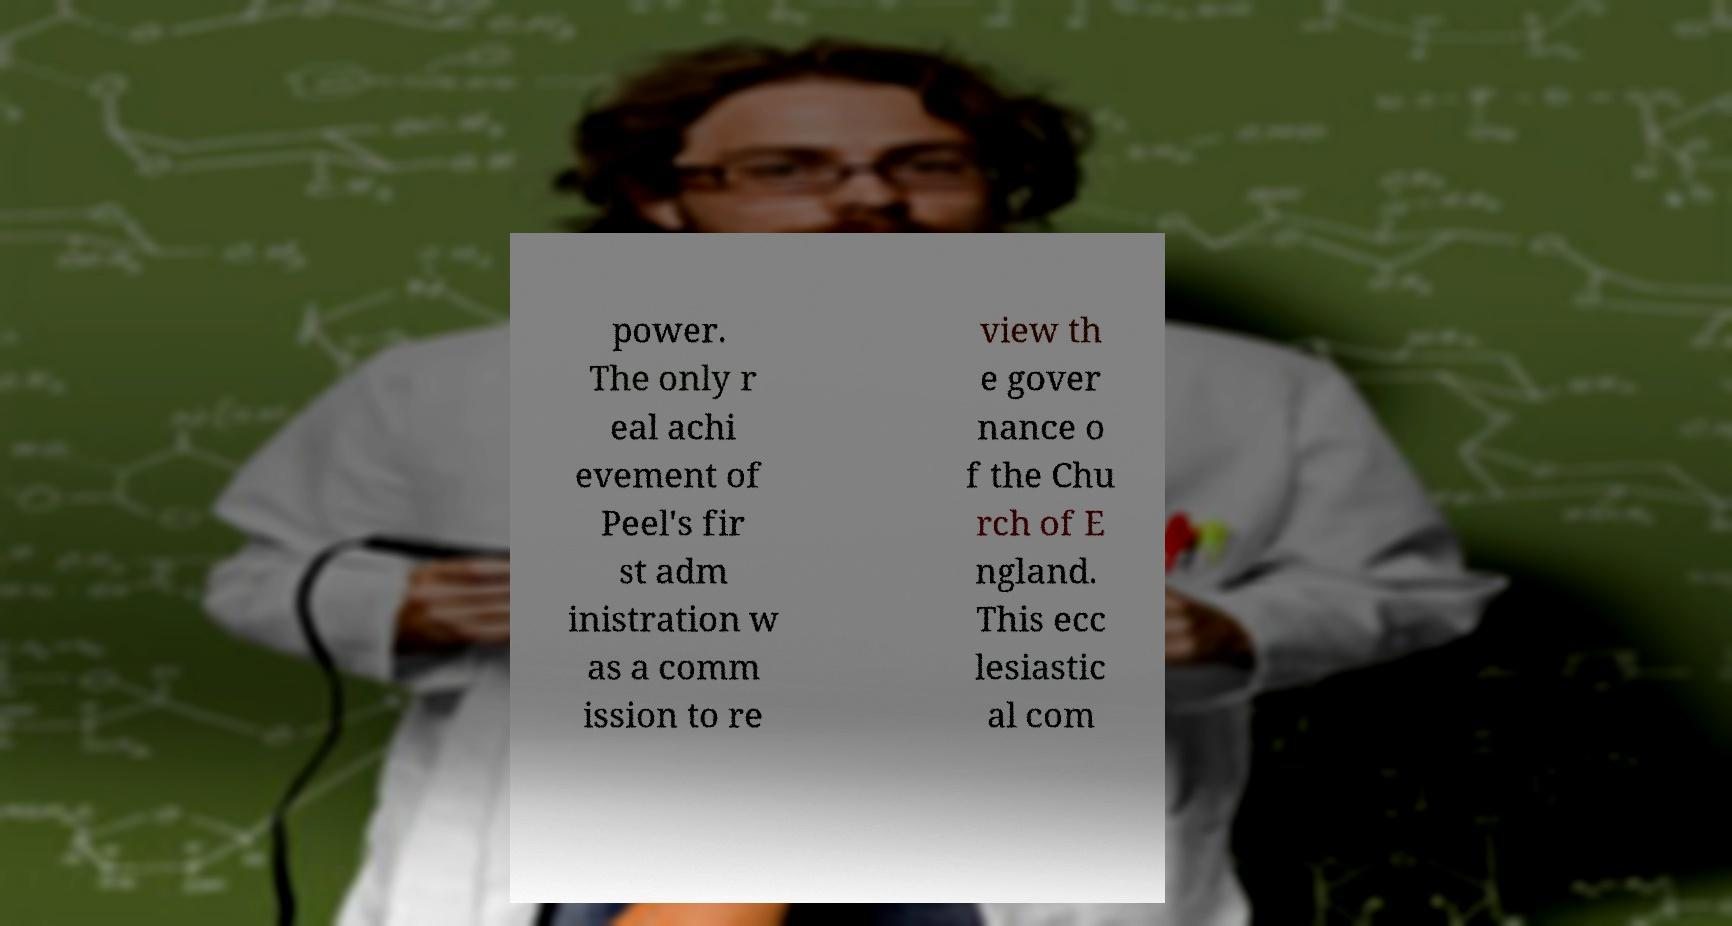I need the written content from this picture converted into text. Can you do that? power. The only r eal achi evement of Peel's fir st adm inistration w as a comm ission to re view th e gover nance o f the Chu rch of E ngland. This ecc lesiastic al com 